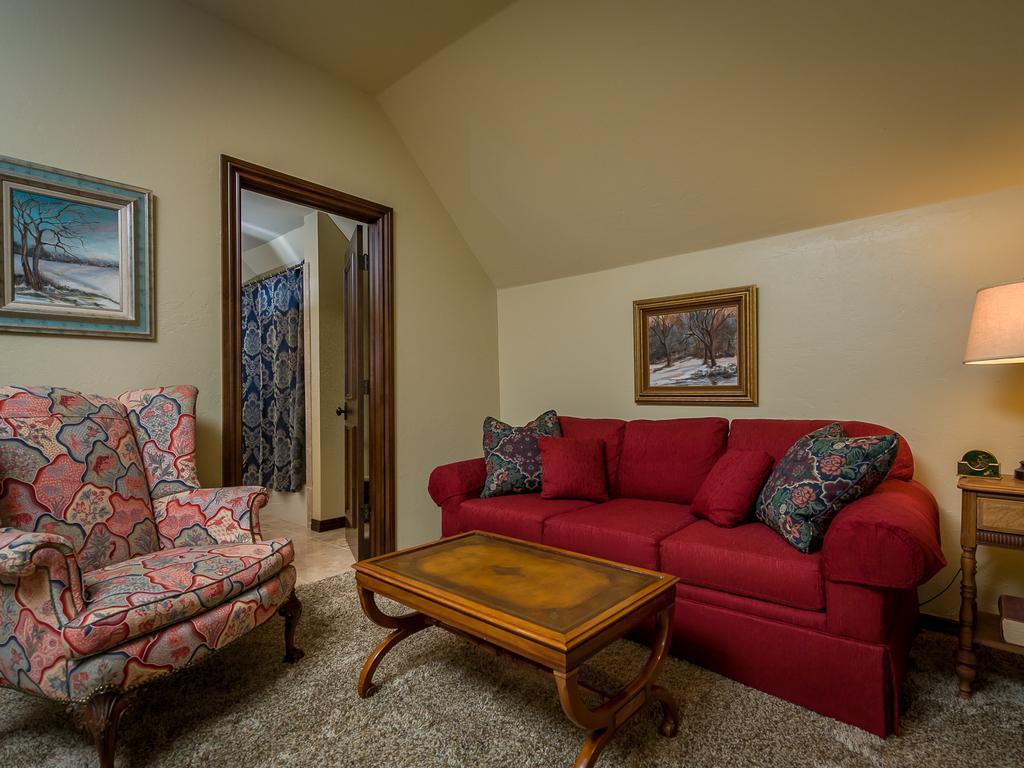What type of furniture is present in the image? There is a table and two couches in the image. How many pillows are visible in the image? There are four pillows in the image. What is on the table in the image? There is a lamp on the table in the image. What is attached to the wall in the image? There is a frame attached to a wall in the image. What architectural feature can be seen in the background of the image? There is a door visible in the background of the image. What type of window treatment is present in the image? There is a curtain in the background of the image. How much money is being exchanged at the market in the image? There is no market or money exchange present in the image. What color are the toenails of the person sitting on the couch? There is no person visible in the image, so it is impossible to determine the color of their toenails. 